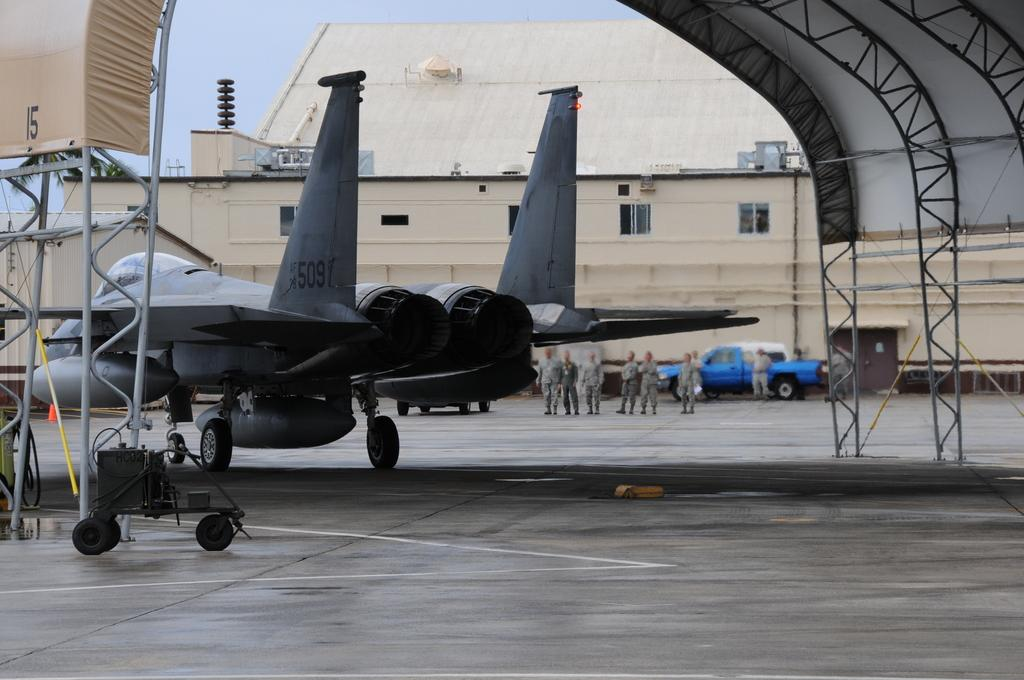<image>
Give a short and clear explanation of the subsequent image. A jet sitting in a military air hangar with the numbers 509 written on its rudder. 